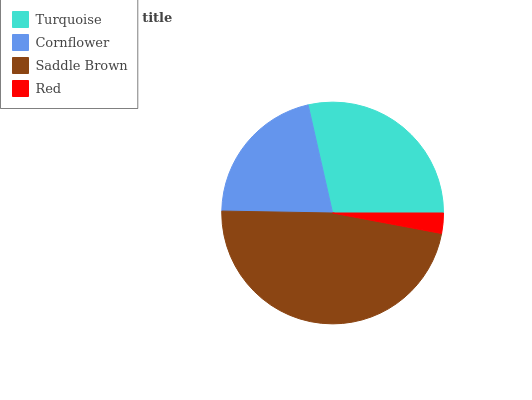Is Red the minimum?
Answer yes or no. Yes. Is Saddle Brown the maximum?
Answer yes or no. Yes. Is Cornflower the minimum?
Answer yes or no. No. Is Cornflower the maximum?
Answer yes or no. No. Is Turquoise greater than Cornflower?
Answer yes or no. Yes. Is Cornflower less than Turquoise?
Answer yes or no. Yes. Is Cornflower greater than Turquoise?
Answer yes or no. No. Is Turquoise less than Cornflower?
Answer yes or no. No. Is Turquoise the high median?
Answer yes or no. Yes. Is Cornflower the low median?
Answer yes or no. Yes. Is Saddle Brown the high median?
Answer yes or no. No. Is Turquoise the low median?
Answer yes or no. No. 